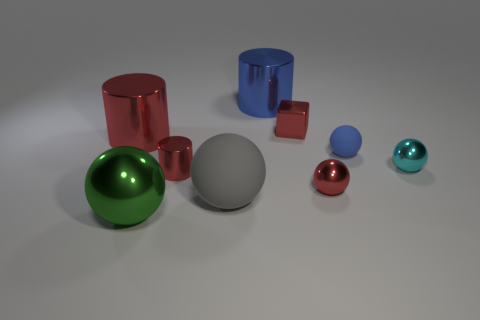Subtract 2 balls. How many balls are left? 3 Subtract all big shiny balls. How many balls are left? 4 Subtract all brown spheres. Subtract all brown cylinders. How many spheres are left? 5 Subtract all spheres. How many objects are left? 4 Add 7 gray matte objects. How many gray matte objects are left? 8 Add 9 blue balls. How many blue balls exist? 10 Subtract 0 brown cylinders. How many objects are left? 9 Subtract all small purple blocks. Subtract all blue metallic cylinders. How many objects are left? 8 